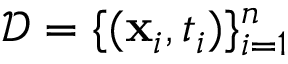Convert formula to latex. <formula><loc_0><loc_0><loc_500><loc_500>\mathcal { D } = \{ ( x _ { i } , t _ { i } ) \} _ { i = 1 } ^ { n }</formula> 